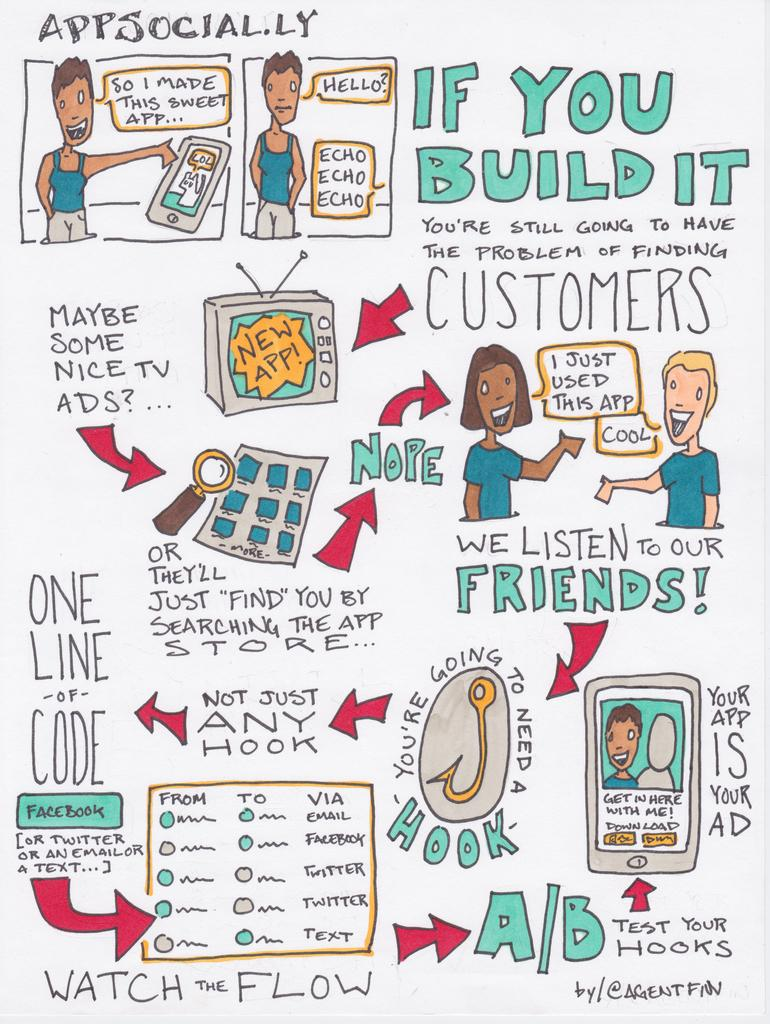What can be seen in the foreground of the image? In the foreground of the image, there is text, images of a television, images of people, arrows, and dialogue boxes. Can you describe the images of people in the foreground? The images of people in the foreground show various individuals. What is the purpose of the arrows in the foreground? The arrows in the foreground are likely used to indicate direction or movement. What type of communication is represented by the dialogue boxes in the foreground? The dialogue boxes in the foreground may represent speech or thought bubbles in a comic strip or graphic novel. How many people are running in the cellar in the image? There is no cellar or people running in the image; it features text, images of a television, images of people, arrows, and dialogue boxes in the foreground. What type of crowd is visible in the image? There is no crowd visible in the image; it features text, images of a television, images of people, arrows, and dialogue boxes in the foreground. 